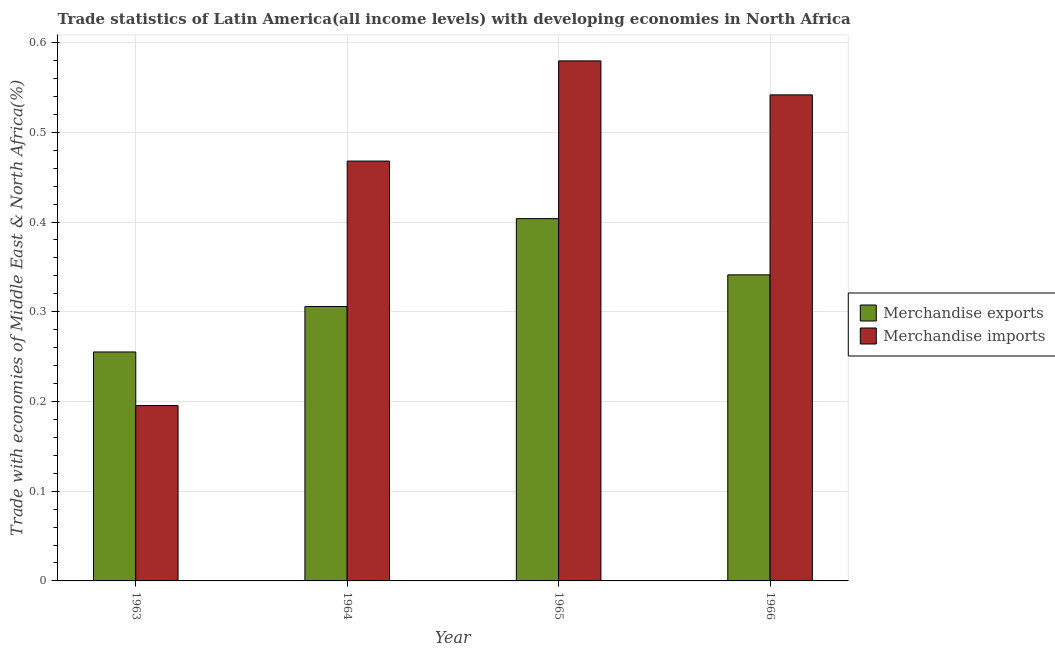How many different coloured bars are there?
Your answer should be compact. 2. How many groups of bars are there?
Give a very brief answer. 4. Are the number of bars per tick equal to the number of legend labels?
Your answer should be very brief. Yes. How many bars are there on the 3rd tick from the left?
Your response must be concise. 2. How many bars are there on the 2nd tick from the right?
Ensure brevity in your answer.  2. What is the label of the 3rd group of bars from the left?
Keep it short and to the point. 1965. In how many cases, is the number of bars for a given year not equal to the number of legend labels?
Your answer should be compact. 0. What is the merchandise imports in 1965?
Your response must be concise. 0.58. Across all years, what is the maximum merchandise imports?
Make the answer very short. 0.58. Across all years, what is the minimum merchandise exports?
Offer a terse response. 0.26. In which year was the merchandise exports maximum?
Offer a terse response. 1965. What is the total merchandise exports in the graph?
Your response must be concise. 1.31. What is the difference between the merchandise exports in 1963 and that in 1965?
Offer a terse response. -0.15. What is the difference between the merchandise exports in 1965 and the merchandise imports in 1964?
Offer a terse response. 0.1. What is the average merchandise exports per year?
Give a very brief answer. 0.33. What is the ratio of the merchandise exports in 1965 to that in 1966?
Ensure brevity in your answer.  1.18. Is the merchandise exports in 1965 less than that in 1966?
Your response must be concise. No. What is the difference between the highest and the second highest merchandise imports?
Offer a terse response. 0.04. What is the difference between the highest and the lowest merchandise imports?
Give a very brief answer. 0.38. In how many years, is the merchandise exports greater than the average merchandise exports taken over all years?
Provide a succinct answer. 2. Is the sum of the merchandise imports in 1963 and 1965 greater than the maximum merchandise exports across all years?
Ensure brevity in your answer.  Yes. What does the 2nd bar from the right in 1963 represents?
Your answer should be compact. Merchandise exports. Are all the bars in the graph horizontal?
Offer a very short reply. No. What is the difference between two consecutive major ticks on the Y-axis?
Your response must be concise. 0.1. Are the values on the major ticks of Y-axis written in scientific E-notation?
Provide a short and direct response. No. Does the graph contain grids?
Make the answer very short. Yes. Where does the legend appear in the graph?
Ensure brevity in your answer.  Center right. What is the title of the graph?
Your answer should be very brief. Trade statistics of Latin America(all income levels) with developing economies in North Africa. Does "Grants" appear as one of the legend labels in the graph?
Keep it short and to the point. No. What is the label or title of the X-axis?
Offer a terse response. Year. What is the label or title of the Y-axis?
Make the answer very short. Trade with economies of Middle East & North Africa(%). What is the Trade with economies of Middle East & North Africa(%) of Merchandise exports in 1963?
Give a very brief answer. 0.26. What is the Trade with economies of Middle East & North Africa(%) in Merchandise imports in 1963?
Keep it short and to the point. 0.2. What is the Trade with economies of Middle East & North Africa(%) of Merchandise exports in 1964?
Ensure brevity in your answer.  0.31. What is the Trade with economies of Middle East & North Africa(%) of Merchandise imports in 1964?
Make the answer very short. 0.47. What is the Trade with economies of Middle East & North Africa(%) in Merchandise exports in 1965?
Give a very brief answer. 0.4. What is the Trade with economies of Middle East & North Africa(%) of Merchandise imports in 1965?
Keep it short and to the point. 0.58. What is the Trade with economies of Middle East & North Africa(%) in Merchandise exports in 1966?
Offer a very short reply. 0.34. What is the Trade with economies of Middle East & North Africa(%) of Merchandise imports in 1966?
Your answer should be compact. 0.54. Across all years, what is the maximum Trade with economies of Middle East & North Africa(%) of Merchandise exports?
Offer a terse response. 0.4. Across all years, what is the maximum Trade with economies of Middle East & North Africa(%) in Merchandise imports?
Keep it short and to the point. 0.58. Across all years, what is the minimum Trade with economies of Middle East & North Africa(%) of Merchandise exports?
Your answer should be very brief. 0.26. Across all years, what is the minimum Trade with economies of Middle East & North Africa(%) of Merchandise imports?
Your answer should be very brief. 0.2. What is the total Trade with economies of Middle East & North Africa(%) in Merchandise exports in the graph?
Your response must be concise. 1.31. What is the total Trade with economies of Middle East & North Africa(%) of Merchandise imports in the graph?
Provide a succinct answer. 1.78. What is the difference between the Trade with economies of Middle East & North Africa(%) of Merchandise exports in 1963 and that in 1964?
Provide a succinct answer. -0.05. What is the difference between the Trade with economies of Middle East & North Africa(%) in Merchandise imports in 1963 and that in 1964?
Your answer should be very brief. -0.27. What is the difference between the Trade with economies of Middle East & North Africa(%) of Merchandise exports in 1963 and that in 1965?
Your answer should be very brief. -0.15. What is the difference between the Trade with economies of Middle East & North Africa(%) of Merchandise imports in 1963 and that in 1965?
Offer a terse response. -0.38. What is the difference between the Trade with economies of Middle East & North Africa(%) of Merchandise exports in 1963 and that in 1966?
Your response must be concise. -0.09. What is the difference between the Trade with economies of Middle East & North Africa(%) of Merchandise imports in 1963 and that in 1966?
Your answer should be very brief. -0.35. What is the difference between the Trade with economies of Middle East & North Africa(%) of Merchandise exports in 1964 and that in 1965?
Your answer should be very brief. -0.1. What is the difference between the Trade with economies of Middle East & North Africa(%) in Merchandise imports in 1964 and that in 1965?
Keep it short and to the point. -0.11. What is the difference between the Trade with economies of Middle East & North Africa(%) of Merchandise exports in 1964 and that in 1966?
Offer a terse response. -0.04. What is the difference between the Trade with economies of Middle East & North Africa(%) in Merchandise imports in 1964 and that in 1966?
Provide a short and direct response. -0.07. What is the difference between the Trade with economies of Middle East & North Africa(%) of Merchandise exports in 1965 and that in 1966?
Offer a very short reply. 0.06. What is the difference between the Trade with economies of Middle East & North Africa(%) of Merchandise imports in 1965 and that in 1966?
Give a very brief answer. 0.04. What is the difference between the Trade with economies of Middle East & North Africa(%) of Merchandise exports in 1963 and the Trade with economies of Middle East & North Africa(%) of Merchandise imports in 1964?
Your response must be concise. -0.21. What is the difference between the Trade with economies of Middle East & North Africa(%) in Merchandise exports in 1963 and the Trade with economies of Middle East & North Africa(%) in Merchandise imports in 1965?
Offer a terse response. -0.32. What is the difference between the Trade with economies of Middle East & North Africa(%) of Merchandise exports in 1963 and the Trade with economies of Middle East & North Africa(%) of Merchandise imports in 1966?
Your answer should be compact. -0.29. What is the difference between the Trade with economies of Middle East & North Africa(%) of Merchandise exports in 1964 and the Trade with economies of Middle East & North Africa(%) of Merchandise imports in 1965?
Ensure brevity in your answer.  -0.27. What is the difference between the Trade with economies of Middle East & North Africa(%) in Merchandise exports in 1964 and the Trade with economies of Middle East & North Africa(%) in Merchandise imports in 1966?
Give a very brief answer. -0.24. What is the difference between the Trade with economies of Middle East & North Africa(%) of Merchandise exports in 1965 and the Trade with economies of Middle East & North Africa(%) of Merchandise imports in 1966?
Give a very brief answer. -0.14. What is the average Trade with economies of Middle East & North Africa(%) of Merchandise exports per year?
Make the answer very short. 0.33. What is the average Trade with economies of Middle East & North Africa(%) in Merchandise imports per year?
Give a very brief answer. 0.45. In the year 1963, what is the difference between the Trade with economies of Middle East & North Africa(%) in Merchandise exports and Trade with economies of Middle East & North Africa(%) in Merchandise imports?
Your answer should be very brief. 0.06. In the year 1964, what is the difference between the Trade with economies of Middle East & North Africa(%) in Merchandise exports and Trade with economies of Middle East & North Africa(%) in Merchandise imports?
Your response must be concise. -0.16. In the year 1965, what is the difference between the Trade with economies of Middle East & North Africa(%) in Merchandise exports and Trade with economies of Middle East & North Africa(%) in Merchandise imports?
Keep it short and to the point. -0.18. In the year 1966, what is the difference between the Trade with economies of Middle East & North Africa(%) in Merchandise exports and Trade with economies of Middle East & North Africa(%) in Merchandise imports?
Make the answer very short. -0.2. What is the ratio of the Trade with economies of Middle East & North Africa(%) in Merchandise exports in 1963 to that in 1964?
Offer a very short reply. 0.83. What is the ratio of the Trade with economies of Middle East & North Africa(%) of Merchandise imports in 1963 to that in 1964?
Provide a short and direct response. 0.42. What is the ratio of the Trade with economies of Middle East & North Africa(%) of Merchandise exports in 1963 to that in 1965?
Make the answer very short. 0.63. What is the ratio of the Trade with economies of Middle East & North Africa(%) in Merchandise imports in 1963 to that in 1965?
Give a very brief answer. 0.34. What is the ratio of the Trade with economies of Middle East & North Africa(%) of Merchandise exports in 1963 to that in 1966?
Make the answer very short. 0.75. What is the ratio of the Trade with economies of Middle East & North Africa(%) of Merchandise imports in 1963 to that in 1966?
Offer a terse response. 0.36. What is the ratio of the Trade with economies of Middle East & North Africa(%) of Merchandise exports in 1964 to that in 1965?
Offer a terse response. 0.76. What is the ratio of the Trade with economies of Middle East & North Africa(%) in Merchandise imports in 1964 to that in 1965?
Offer a very short reply. 0.81. What is the ratio of the Trade with economies of Middle East & North Africa(%) in Merchandise exports in 1964 to that in 1966?
Give a very brief answer. 0.9. What is the ratio of the Trade with economies of Middle East & North Africa(%) in Merchandise imports in 1964 to that in 1966?
Give a very brief answer. 0.86. What is the ratio of the Trade with economies of Middle East & North Africa(%) of Merchandise exports in 1965 to that in 1966?
Your answer should be compact. 1.18. What is the ratio of the Trade with economies of Middle East & North Africa(%) in Merchandise imports in 1965 to that in 1966?
Offer a very short reply. 1.07. What is the difference between the highest and the second highest Trade with economies of Middle East & North Africa(%) in Merchandise exports?
Provide a short and direct response. 0.06. What is the difference between the highest and the second highest Trade with economies of Middle East & North Africa(%) in Merchandise imports?
Your answer should be very brief. 0.04. What is the difference between the highest and the lowest Trade with economies of Middle East & North Africa(%) of Merchandise exports?
Your response must be concise. 0.15. What is the difference between the highest and the lowest Trade with economies of Middle East & North Africa(%) in Merchandise imports?
Provide a short and direct response. 0.38. 